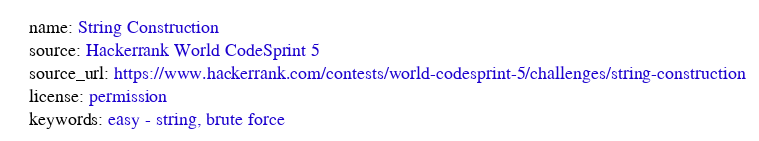<code> <loc_0><loc_0><loc_500><loc_500><_YAML_>name: String Construction
source: Hackerrank World CodeSprint 5
source_url: https://www.hackerrank.com/contests/world-codesprint-5/challenges/string-construction
license: permission
keywords: easy - string, brute force
</code> 